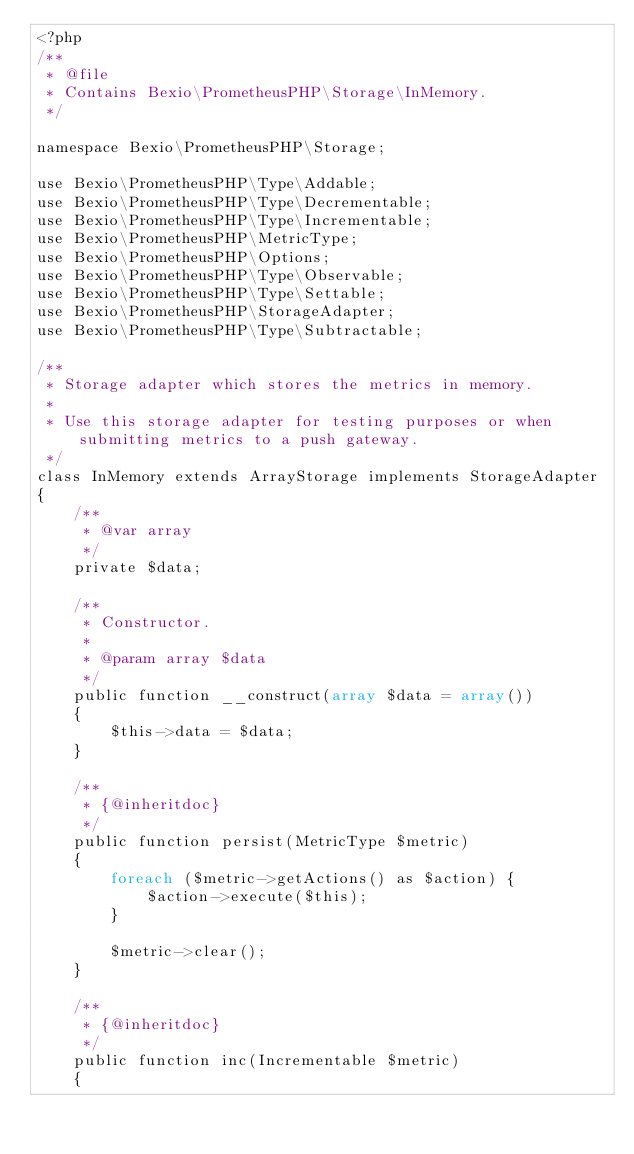<code> <loc_0><loc_0><loc_500><loc_500><_PHP_><?php
/**
 * @file
 * Contains Bexio\PrometheusPHP\Storage\InMemory.
 */

namespace Bexio\PrometheusPHP\Storage;

use Bexio\PrometheusPHP\Type\Addable;
use Bexio\PrometheusPHP\Type\Decrementable;
use Bexio\PrometheusPHP\Type\Incrementable;
use Bexio\PrometheusPHP\MetricType;
use Bexio\PrometheusPHP\Options;
use Bexio\PrometheusPHP\Type\Observable;
use Bexio\PrometheusPHP\Type\Settable;
use Bexio\PrometheusPHP\StorageAdapter;
use Bexio\PrometheusPHP\Type\Subtractable;

/**
 * Storage adapter which stores the metrics in memory.
 *
 * Use this storage adapter for testing purposes or when submitting metrics to a push gateway.
 */
class InMemory extends ArrayStorage implements StorageAdapter
{
    /**
     * @var array
     */
    private $data;

    /**
     * Constructor.
     *
     * @param array $data
     */
    public function __construct(array $data = array())
    {
        $this->data = $data;
    }

    /**
     * {@inheritdoc}
     */
    public function persist(MetricType $metric)
    {
        foreach ($metric->getActions() as $action) {
            $action->execute($this);
        }

        $metric->clear();
    }

    /**
     * {@inheritdoc}
     */
    public function inc(Incrementable $metric)
    {</code> 